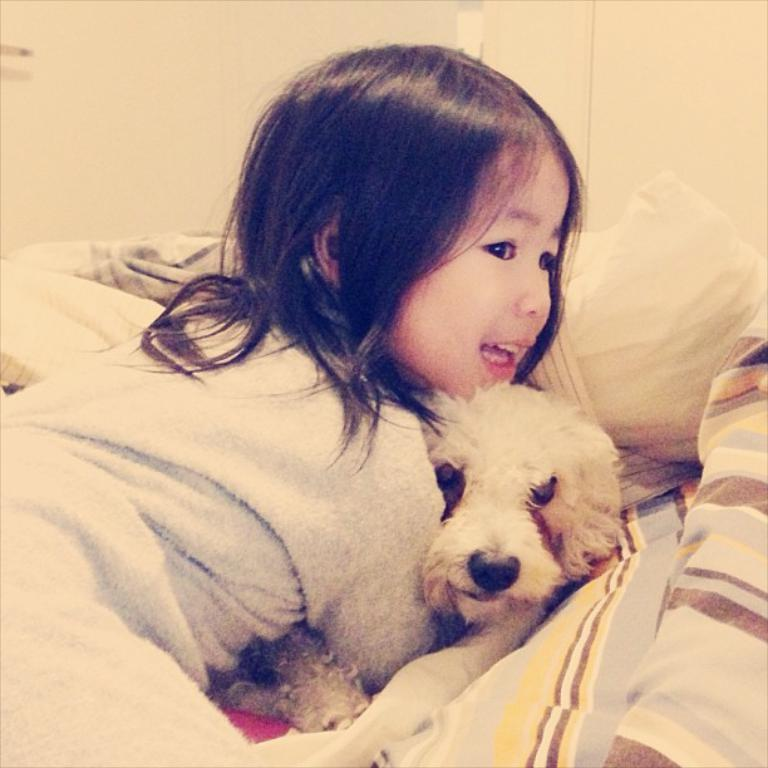Who is in the image? There is a girl in the image. What is the girl doing in the image? The girl is smiling and holding a dog. Where is the girl located in the image? The girl is lying on a bed. What can be seen in the background of the image? There is a wall visible in the background. What arithmetic problem is the girl solving in the image? There is no arithmetic problem present in the image; the girl is holding a dog and lying on a bed. Can you see a goose in the image? No, there is no goose present in the image. 